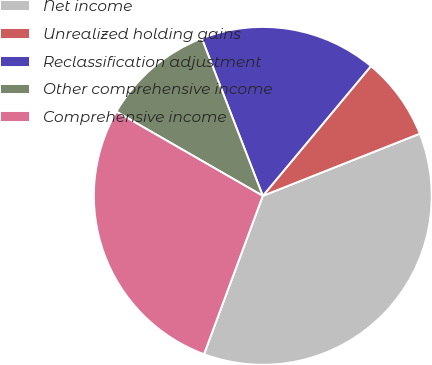Convert chart. <chart><loc_0><loc_0><loc_500><loc_500><pie_chart><fcel>Net income<fcel>Unrealized holding gains<fcel>Reclassification adjustment<fcel>Other comprehensive income<fcel>Comprehensive income<nl><fcel>36.66%<fcel>7.94%<fcel>16.94%<fcel>10.81%<fcel>27.65%<nl></chart> 